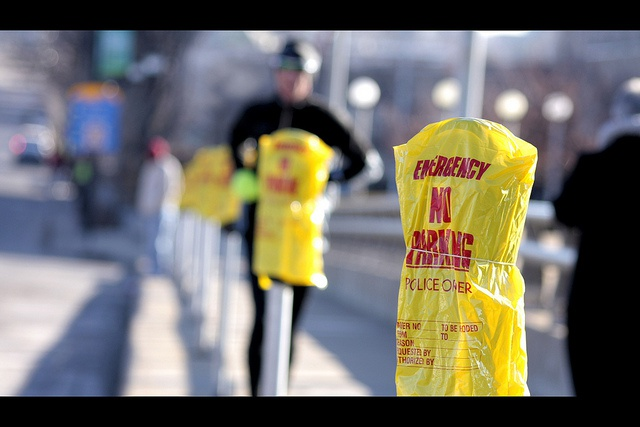Describe the objects in this image and their specific colors. I can see parking meter in black, olive, gold, khaki, and tan tones, people in black and gray tones, parking meter in black, tan, gold, white, and darkgray tones, people in black, gray, darkgray, and lightgray tones, and people in black, darkgray, and gray tones in this image. 